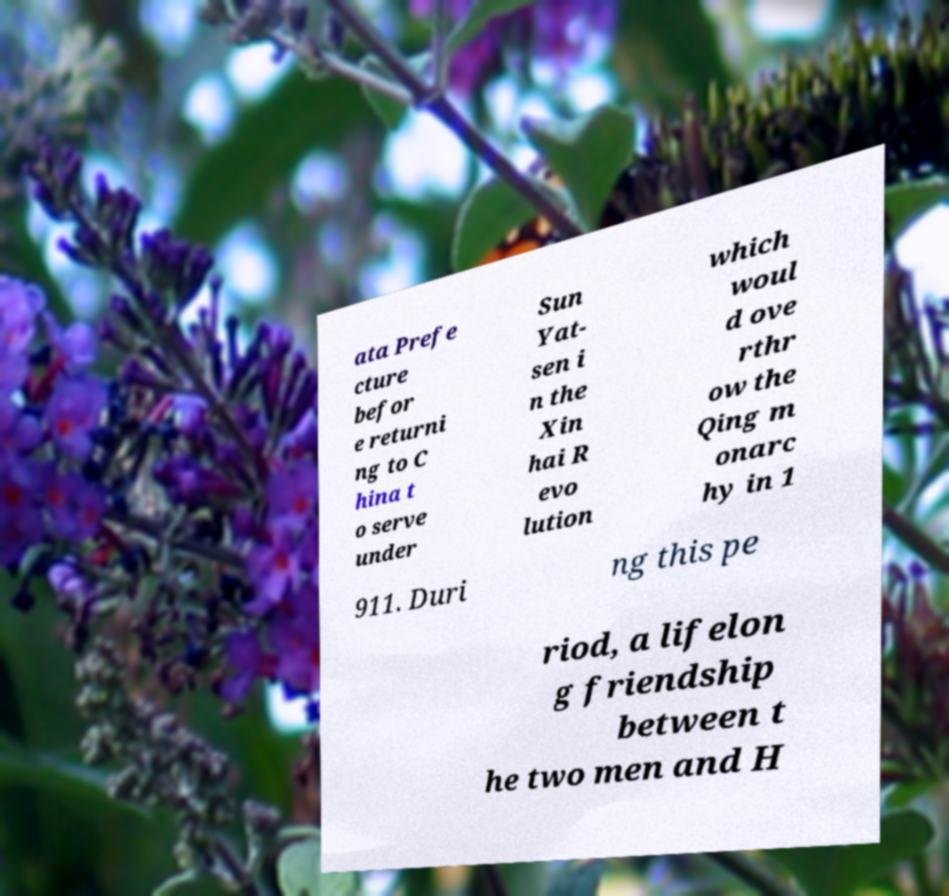Please identify and transcribe the text found in this image. ata Prefe cture befor e returni ng to C hina t o serve under Sun Yat- sen i n the Xin hai R evo lution which woul d ove rthr ow the Qing m onarc hy in 1 911. Duri ng this pe riod, a lifelon g friendship between t he two men and H 